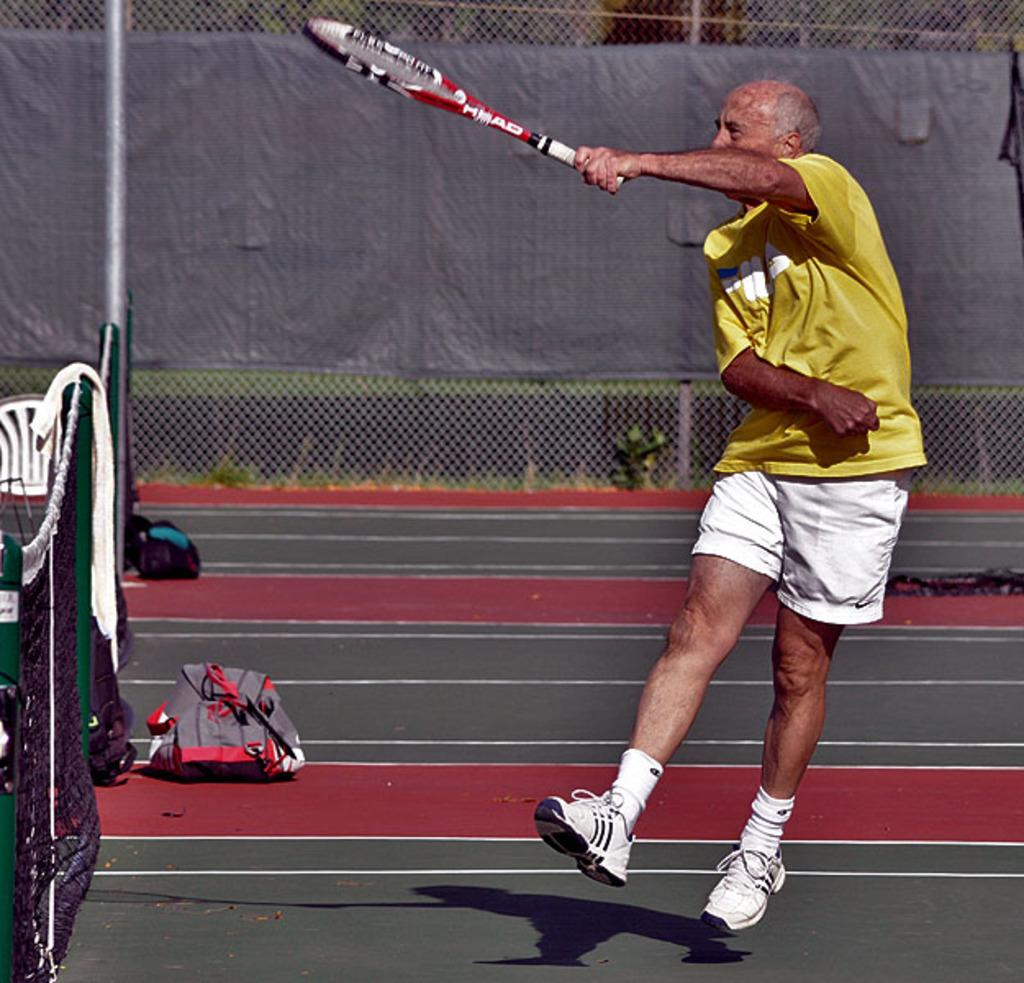Who is present in the image? There is a man in the image. What is the man holding in the image? The man is holding a racket. What object can be seen on the floor in the image? There is a bag on the floor. Can you describe the object in the background that is covered with cloth? There is a cloth-covered object in the background. What type of reaction can be seen in the vase in the image? There is no vase present in the image, so it is not possible to determine any reaction within a vase. 